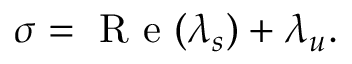<formula> <loc_0><loc_0><loc_500><loc_500>\sigma = R e ( \lambda _ { s } ) + \lambda _ { u } .</formula> 